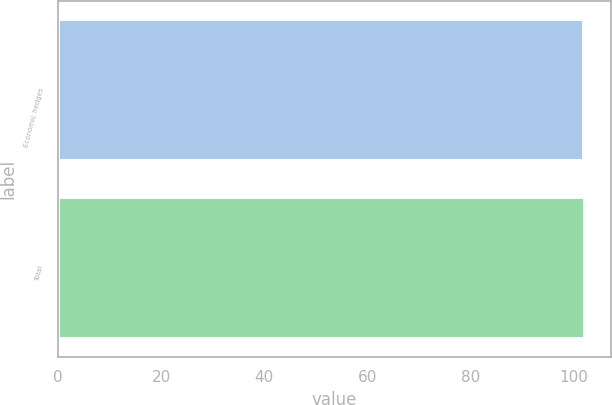Convert chart. <chart><loc_0><loc_0><loc_500><loc_500><bar_chart><fcel>Economic hedges<fcel>Total<nl><fcel>102<fcel>102.1<nl></chart> 